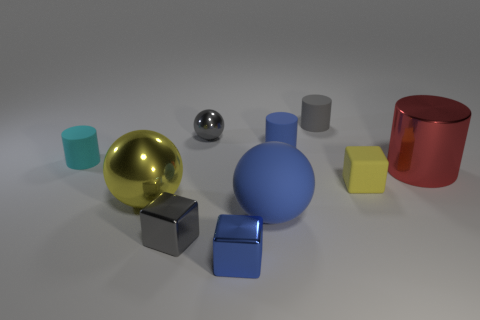Are there fewer small shiny cubes in front of the tiny blue cube than cyan metallic blocks?
Keep it short and to the point. No. What number of other objects are the same material as the cyan object?
Offer a terse response. 4. Do the yellow metallic thing and the blue metallic object have the same size?
Your response must be concise. No. What number of things are either rubber cylinders that are on the left side of the tiny gray rubber object or small blocks?
Give a very brief answer. 5. The blue thing behind the metal thing that is to the right of the gray matte cylinder is made of what material?
Your answer should be very brief. Rubber. Are there any blue shiny things of the same shape as the cyan object?
Keep it short and to the point. No. There is a blue ball; is its size the same as the metal thing behind the red shiny thing?
Your answer should be very brief. No. What number of things are small blue objects that are in front of the large red metal thing or small gray objects that are left of the tiny blue matte object?
Keep it short and to the point. 3. Is the number of tiny gray matte things that are on the left side of the large red metallic cylinder greater than the number of purple shiny cubes?
Offer a very short reply. Yes. How many metallic blocks have the same size as the blue cylinder?
Your response must be concise. 2. 